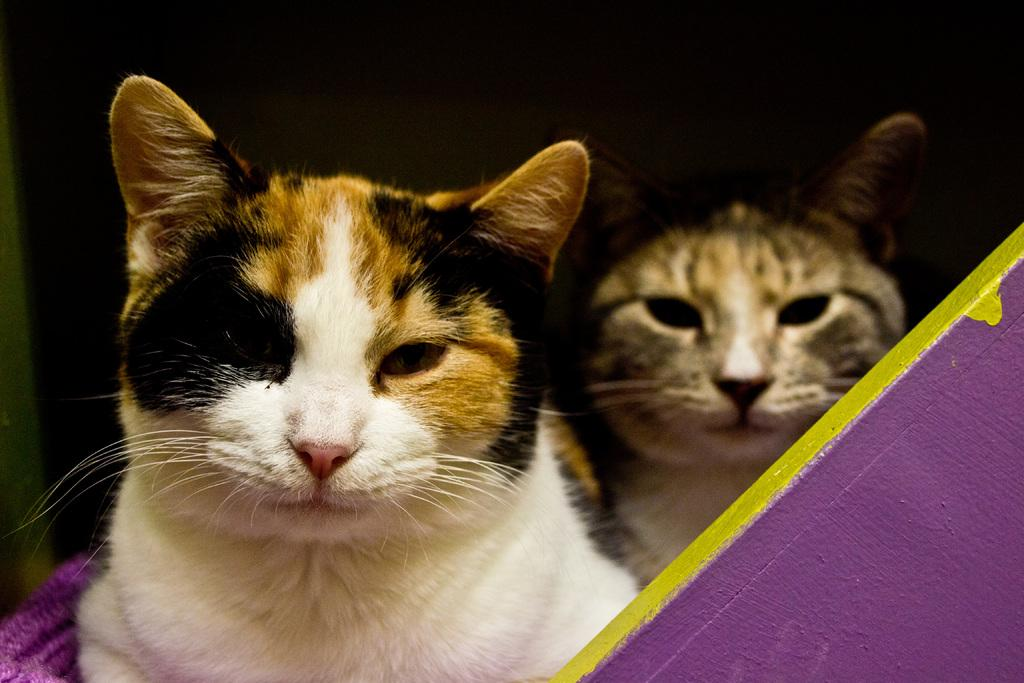What type of animals are in the image? There are cats in the image. What is the main structure or feature in the image? There is a wall in the image. What object resembles a cloth in the image? There is an object that looks like a cloth in the image. How would you describe the overall lighting or brightness in the image? The background of the image is dark. Can you tell me how many divisions are present in the image? There is no mention of divisions or any mathematical concept in the image; it features cats, a wall, and a cloth-like object. 